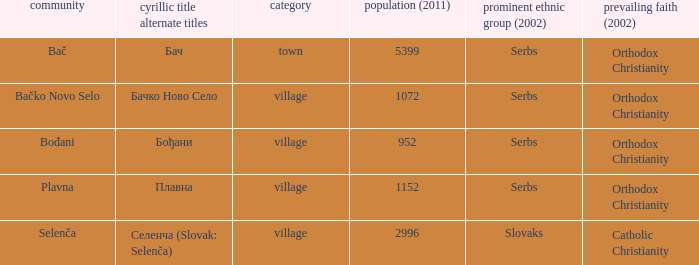Could you parse the entire table as a dict? {'header': ['community', 'cyrillic title alternate titles', 'category', 'population (2011)', 'prominent ethnic group (2002)', 'prevailing faith (2002)'], 'rows': [['Bač', 'Бач', 'town', '5399', 'Serbs', 'Orthodox Christianity'], ['Bačko Novo Selo', 'Бачко Ново Село', 'village', '1072', 'Serbs', 'Orthodox Christianity'], ['Bođani', 'Бођани', 'village', '952', 'Serbs', 'Orthodox Christianity'], ['Plavna', 'Плавна', 'village', '1152', 'Serbs', 'Orthodox Christianity'], ['Selenča', 'Селенча (Slovak: Selenča)', 'village', '2996', 'Slovaks', 'Catholic Christianity']]} What is the smallest population listed? 952.0. 